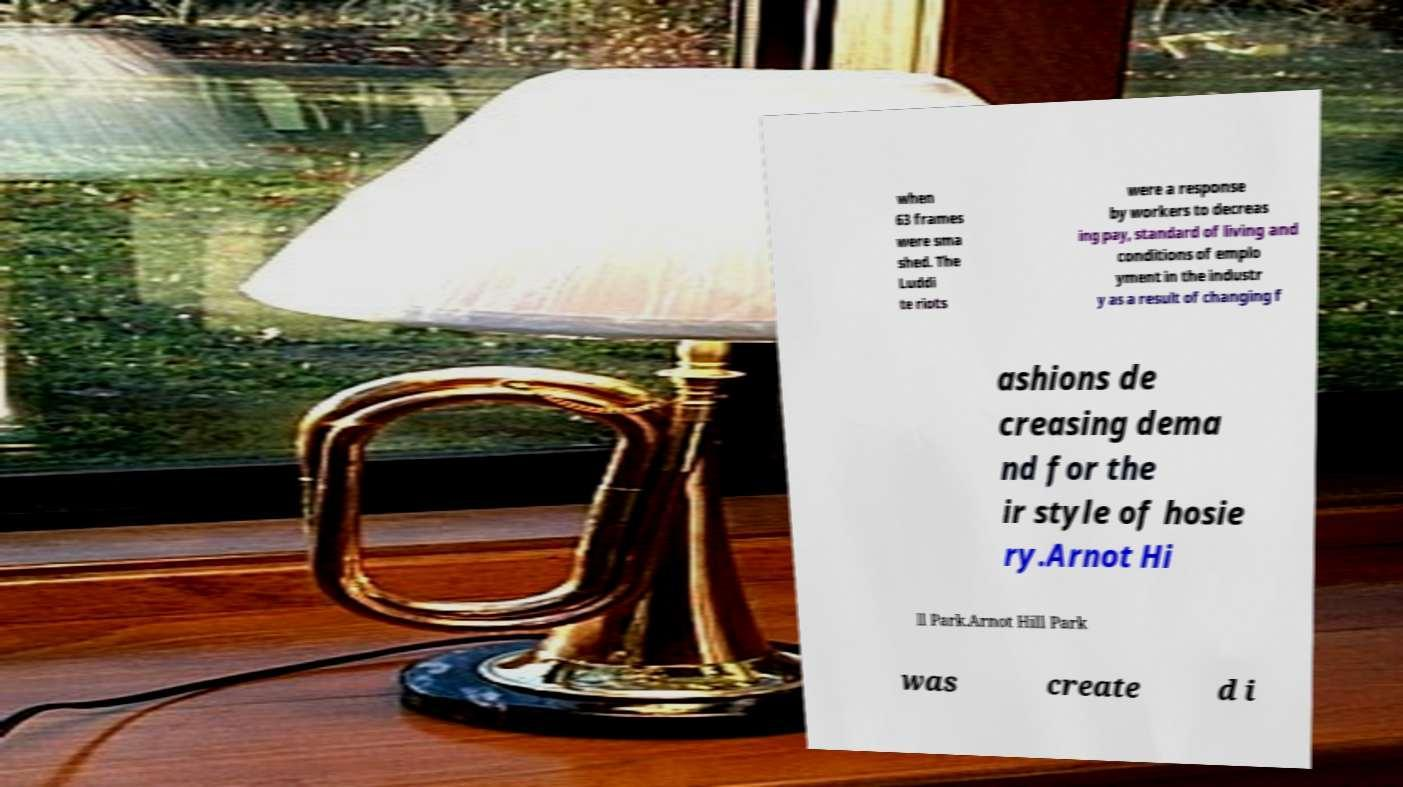For documentation purposes, I need the text within this image transcribed. Could you provide that? when 63 frames were sma shed. The Luddi te riots were a response by workers to decreas ing pay, standard of living and conditions of emplo yment in the industr y as a result of changing f ashions de creasing dema nd for the ir style of hosie ry.Arnot Hi ll Park.Arnot Hill Park was create d i 